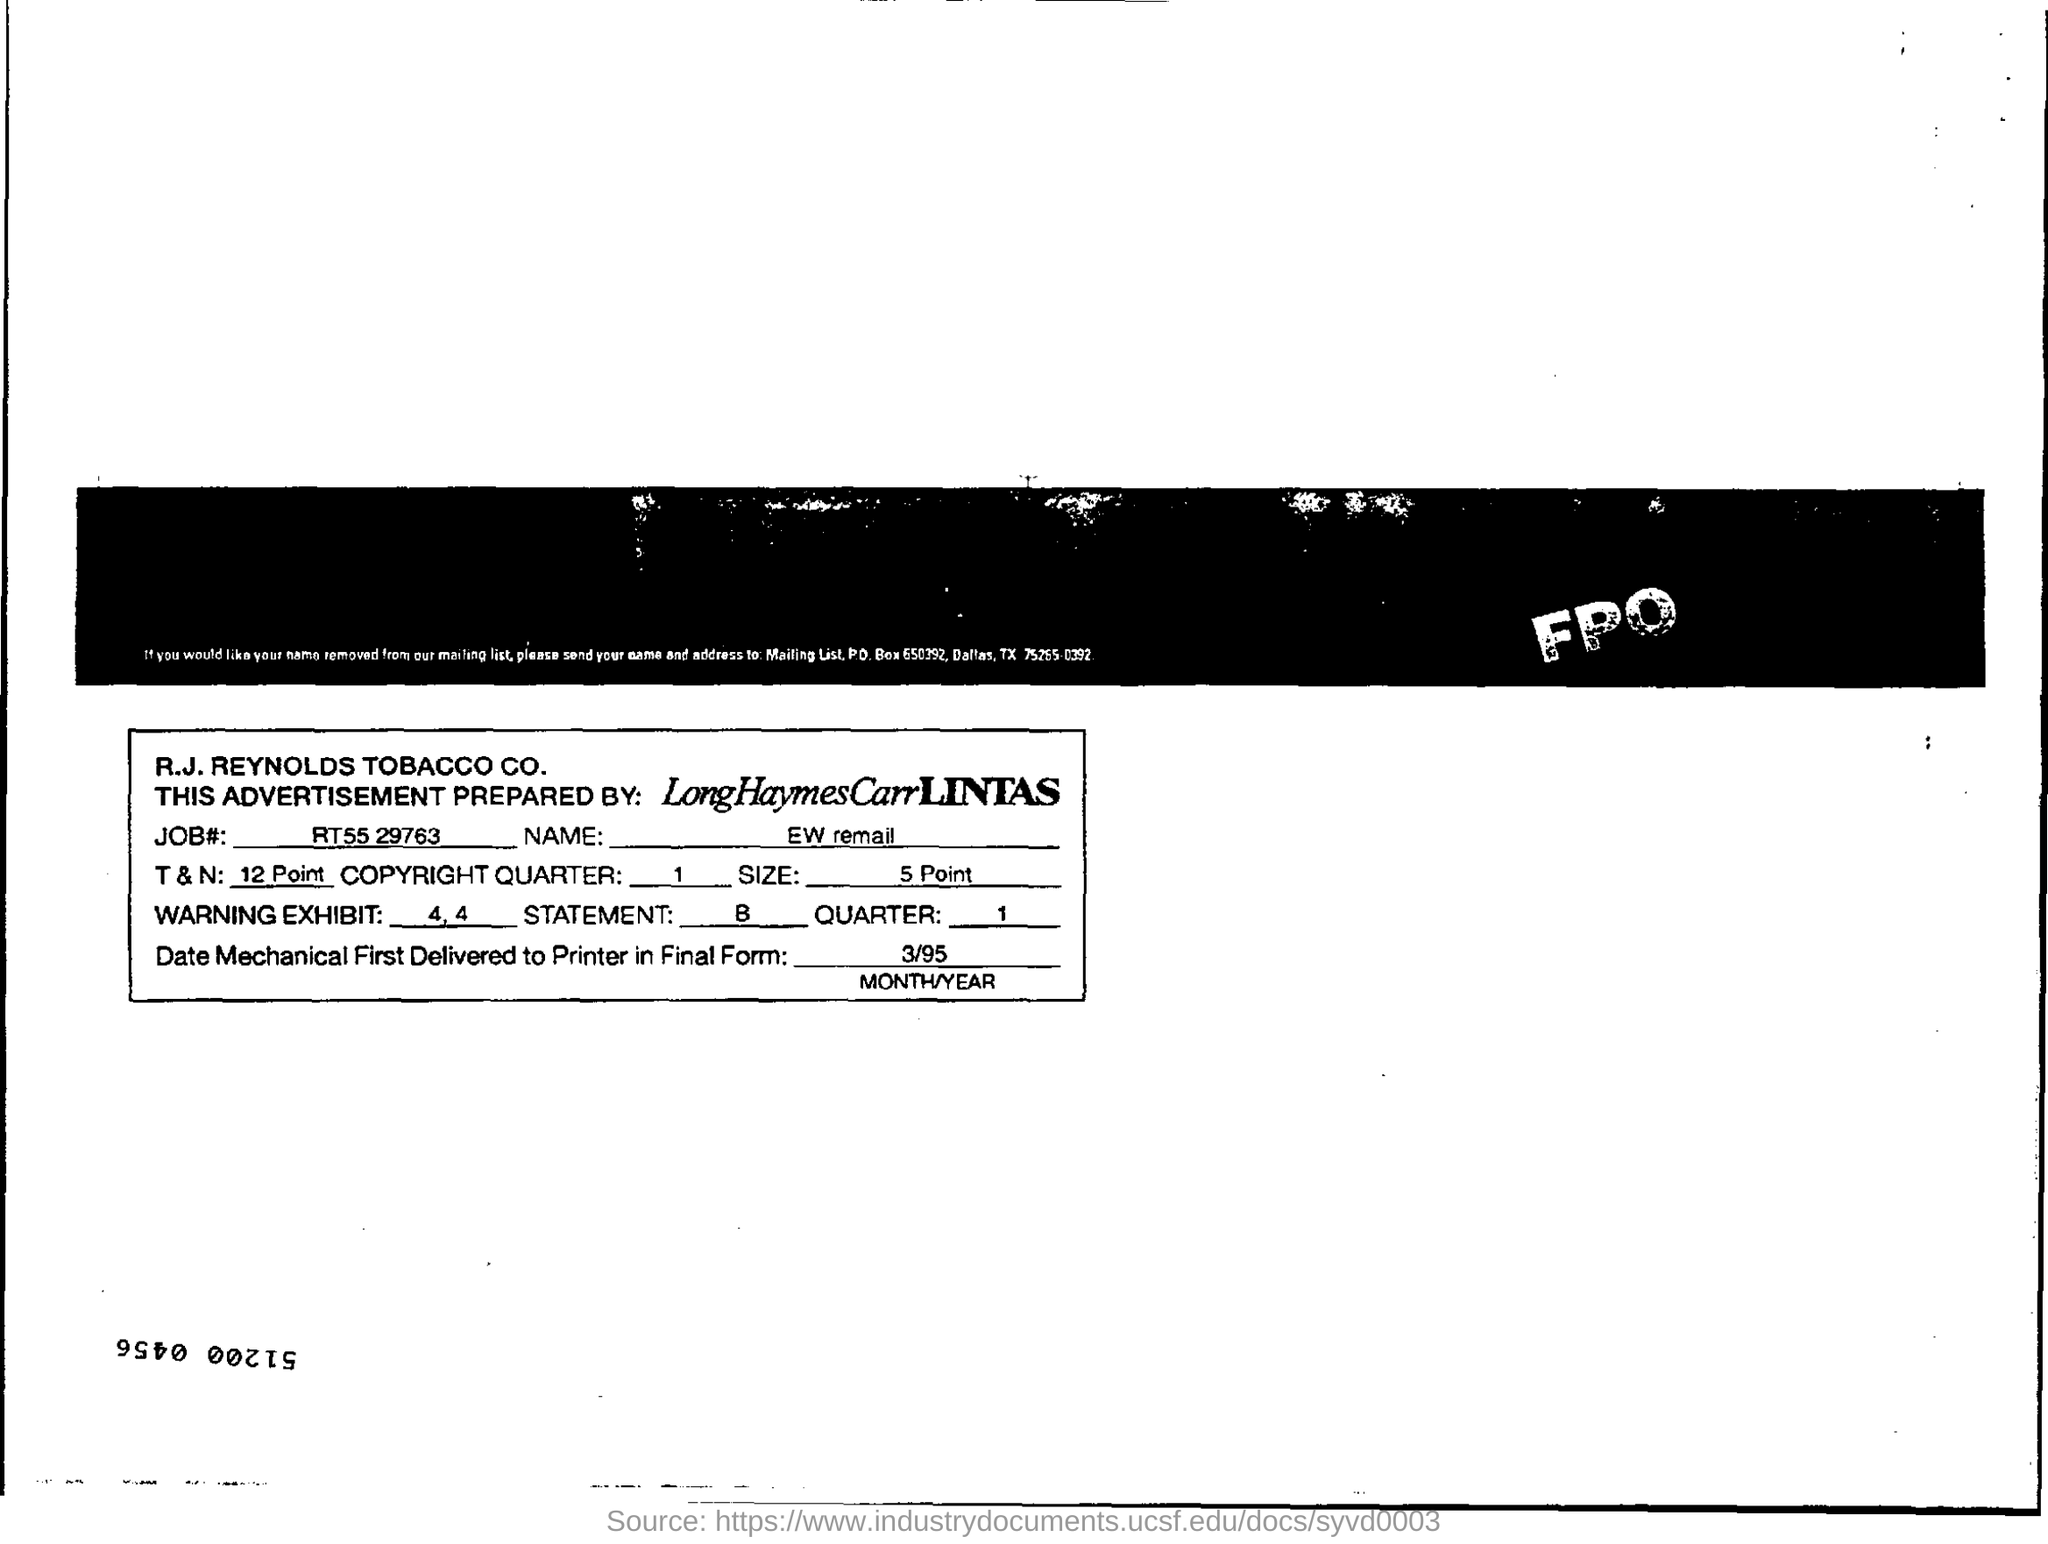Give some essential details in this illustration. The JOB Number is RT55 29763. The advertisement was prepared by LongHaymesCarrLintas. The size is 5 points. 